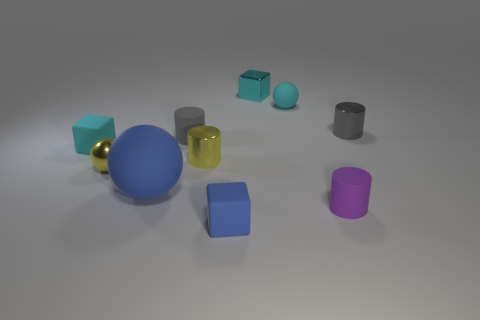Subtract all cyan cubes. How many were subtracted if there are1cyan cubes left? 1 Subtract all cyan cylinders. How many cyan cubes are left? 2 Subtract all cyan blocks. How many blocks are left? 1 Subtract all purple cylinders. How many cylinders are left? 3 Subtract all cylinders. How many objects are left? 6 Add 6 blue rubber things. How many blue rubber things exist? 8 Subtract 0 brown spheres. How many objects are left? 10 Subtract all gray cylinders. Subtract all blue balls. How many cylinders are left? 2 Subtract all small metallic objects. Subtract all big brown metal objects. How many objects are left? 6 Add 2 yellow shiny cylinders. How many yellow shiny cylinders are left? 3 